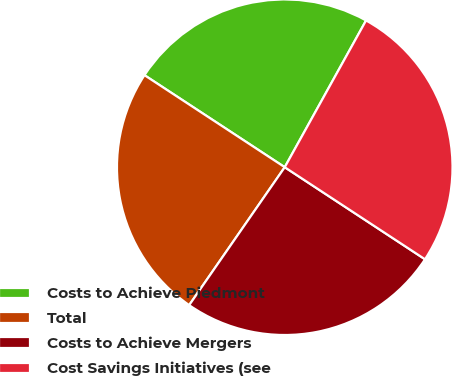<chart> <loc_0><loc_0><loc_500><loc_500><pie_chart><fcel>Costs to Achieve Piedmont<fcel>Total<fcel>Costs to Achieve Mergers<fcel>Cost Savings Initiatives (see<nl><fcel>23.81%<fcel>24.6%<fcel>25.4%<fcel>26.19%<nl></chart> 